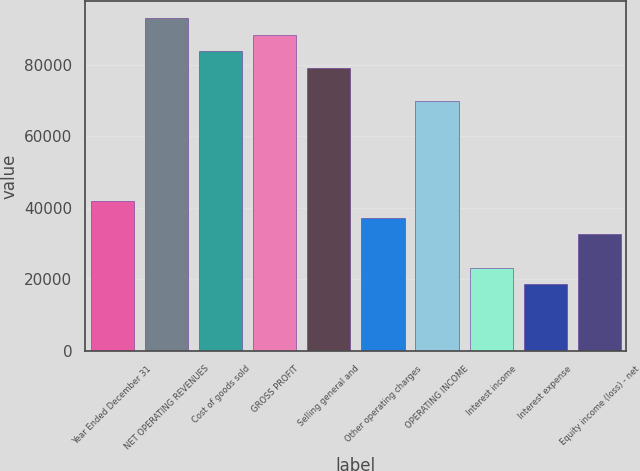Convert chart to OTSL. <chart><loc_0><loc_0><loc_500><loc_500><bar_chart><fcel>Year Ended December 31<fcel>NET OPERATING REVENUES<fcel>Cost of goods sold<fcel>GROSS PROFIT<fcel>Selling general and<fcel>Other operating charges<fcel>OPERATING INCOME<fcel>Interest income<fcel>Interest expense<fcel>Equity income (loss) - net<nl><fcel>41888<fcel>93082.1<fcel>83774.1<fcel>88428.1<fcel>79120.1<fcel>37234<fcel>69812.1<fcel>23271.9<fcel>18617.9<fcel>32580<nl></chart> 